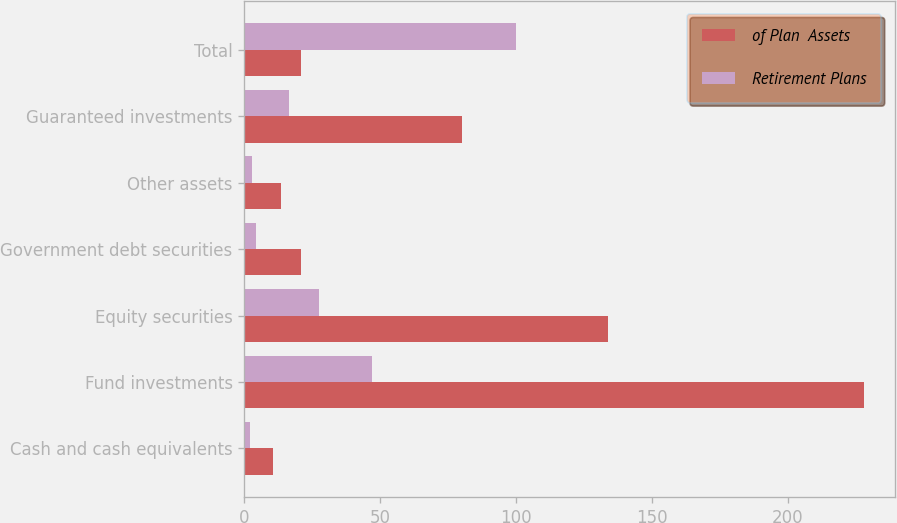Convert chart to OTSL. <chart><loc_0><loc_0><loc_500><loc_500><stacked_bar_chart><ecel><fcel>Cash and cash equivalents<fcel>Fund investments<fcel>Equity securities<fcel>Government debt securities<fcel>Other assets<fcel>Guaranteed investments<fcel>Total<nl><fcel>of Plan  Assets<fcel>10.7<fcel>227.9<fcel>133.9<fcel>20.9<fcel>13.4<fcel>80.1<fcel>20.9<nl><fcel>Retirement Plans<fcel>2.2<fcel>46.8<fcel>27.5<fcel>4.3<fcel>2.8<fcel>16.5<fcel>100<nl></chart> 